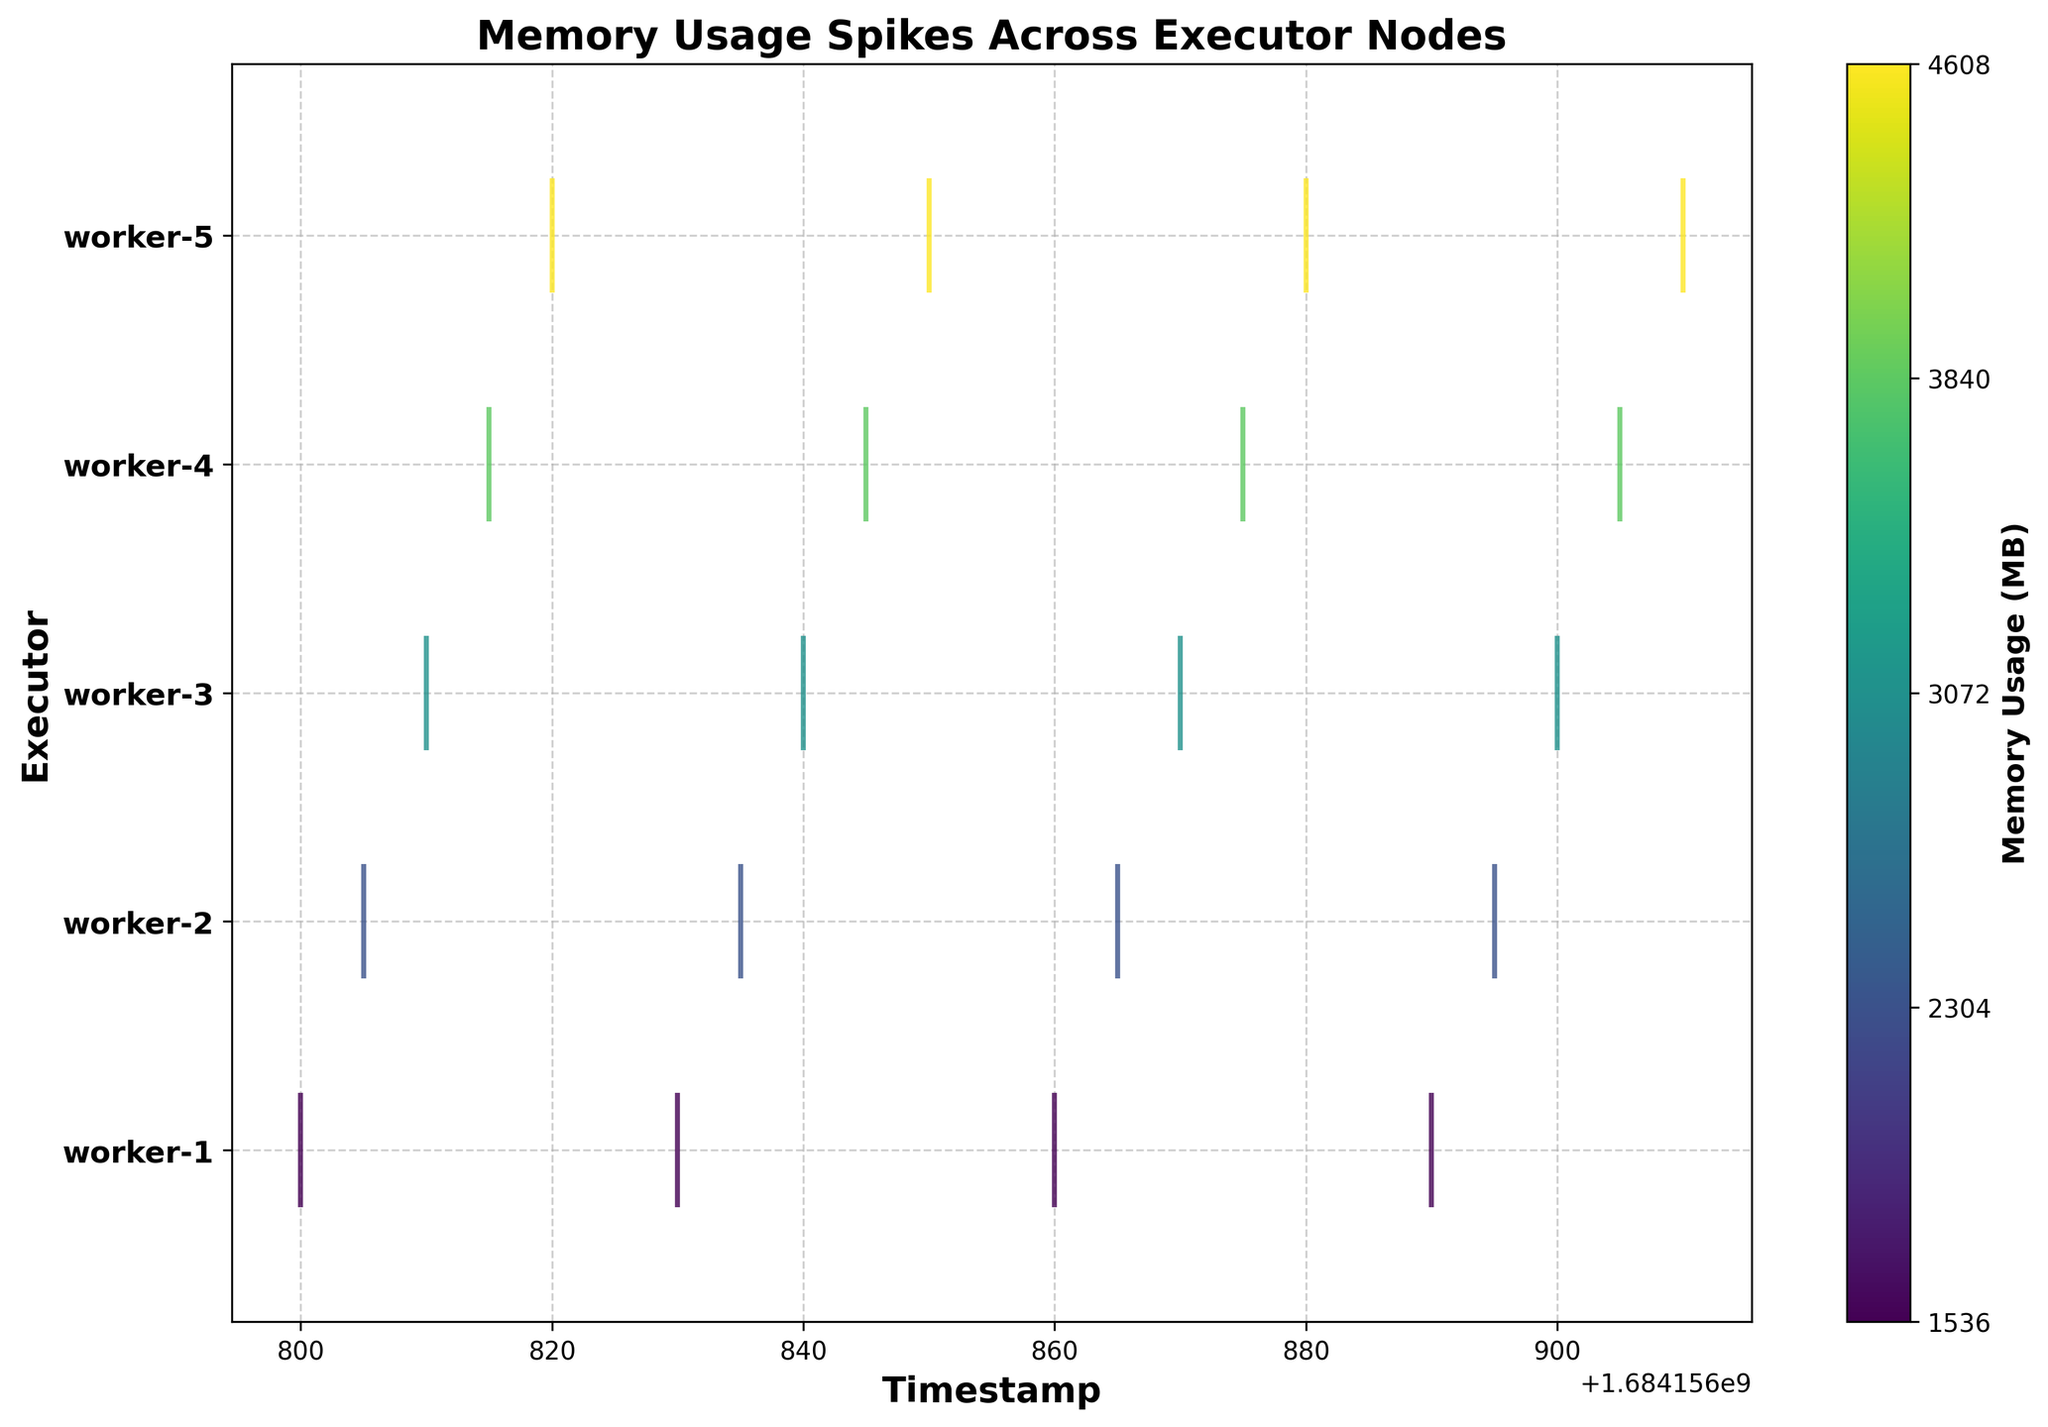What's the title of the plot? The title of the plot is located at the top of the figure and it summarizes the content of the plot.
Answer: Memory Usage Spikes Across Executor Nodes How many executor nodes are represented in the plot? Look at the y-axis where the distinct executors are labeled. Count these labels to determine the total number of executor nodes.
Answer: 5 Which executor node has the highest memory usage spike and at what timestamp does this peak occur? Identify the highest data point on the color map which indicates the maximum memory usage, then trace this data point back to its corresponding executor and timestamp.
Answer: Worker-4, 1684156875 Between which timestamps do most memory usage spikes for Worker-3 occur? Look at the event lines for Worker-3 and observe the concentration of spikes to determine the timestamp range.
Answer: 1684156810 to 1684156900 Compare the memory usage spikes between Worker-1 and Worker-5. Which one has more spikes? Count the number of spikes (events) for Worker-1 and Worker-5 and compare them.
Answer: Worker-1 At what timestamps does Worker-2 experience memory usage spikes? Reference the position of event lines associated with Worker-2 on the x-axis to determine the specific timestamps.
Answer: 1684156805, 1684156835, 1684156865, 1684156895 What's the average memory usage for all executor nodes at the timestamp 1684156830? Locate the memory usage events at timestamp 1684156830, sum these values, and then divide by the number of nodes with data points at this timestamp. Worker-1: 3072, Worker-2: 2560, Worker-3: 2816, Worker-4: 3328, Worker-5: 2944. Sum: 14720/5 = 2944.
Answer: 2944 Which executor node shows a decreasing trend in memory usage after its peak? Identify the spike peaks for each executor, then observe if the subsequent data points are lower.
Answer: Worker-1 What is the memory usage range represented by the color bar? Examine the color bar legend which represents the memory usage values to determine the range. The scale usually maps colors to data values directly.
Answer: 1536 to 4608 MB In terms of timestamps, what is the duration covered in the plot? Assess the range on the x-axis starting from the earliest timestamp to the latest timestamp. Calculate the difference between these two timestamps.
Answer: 1684156800 to 1684156910 (110 seconds) 